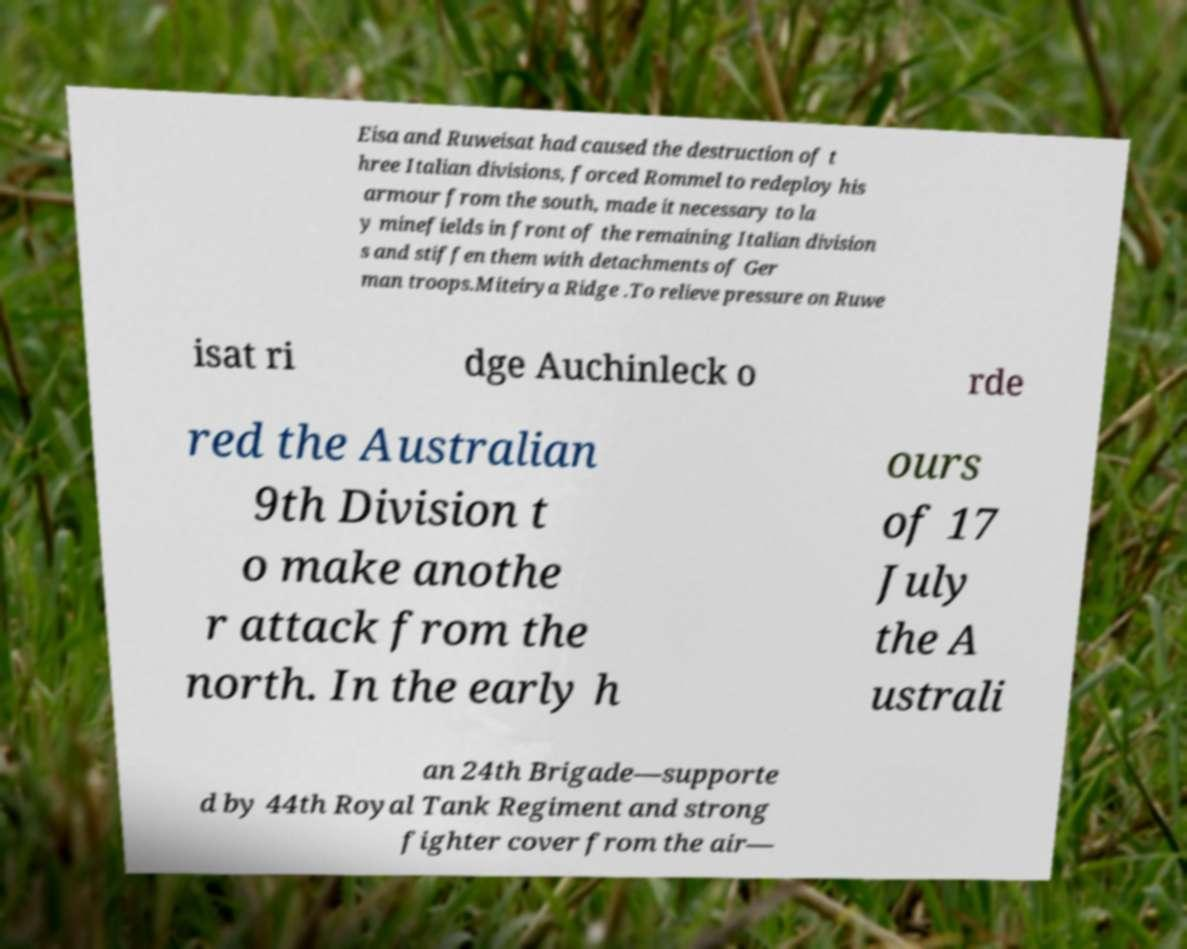Can you read and provide the text displayed in the image?This photo seems to have some interesting text. Can you extract and type it out for me? Eisa and Ruweisat had caused the destruction of t hree Italian divisions, forced Rommel to redeploy his armour from the south, made it necessary to la y minefields in front of the remaining Italian division s and stiffen them with detachments of Ger man troops.Miteirya Ridge .To relieve pressure on Ruwe isat ri dge Auchinleck o rde red the Australian 9th Division t o make anothe r attack from the north. In the early h ours of 17 July the A ustrali an 24th Brigade—supporte d by 44th Royal Tank Regiment and strong fighter cover from the air— 